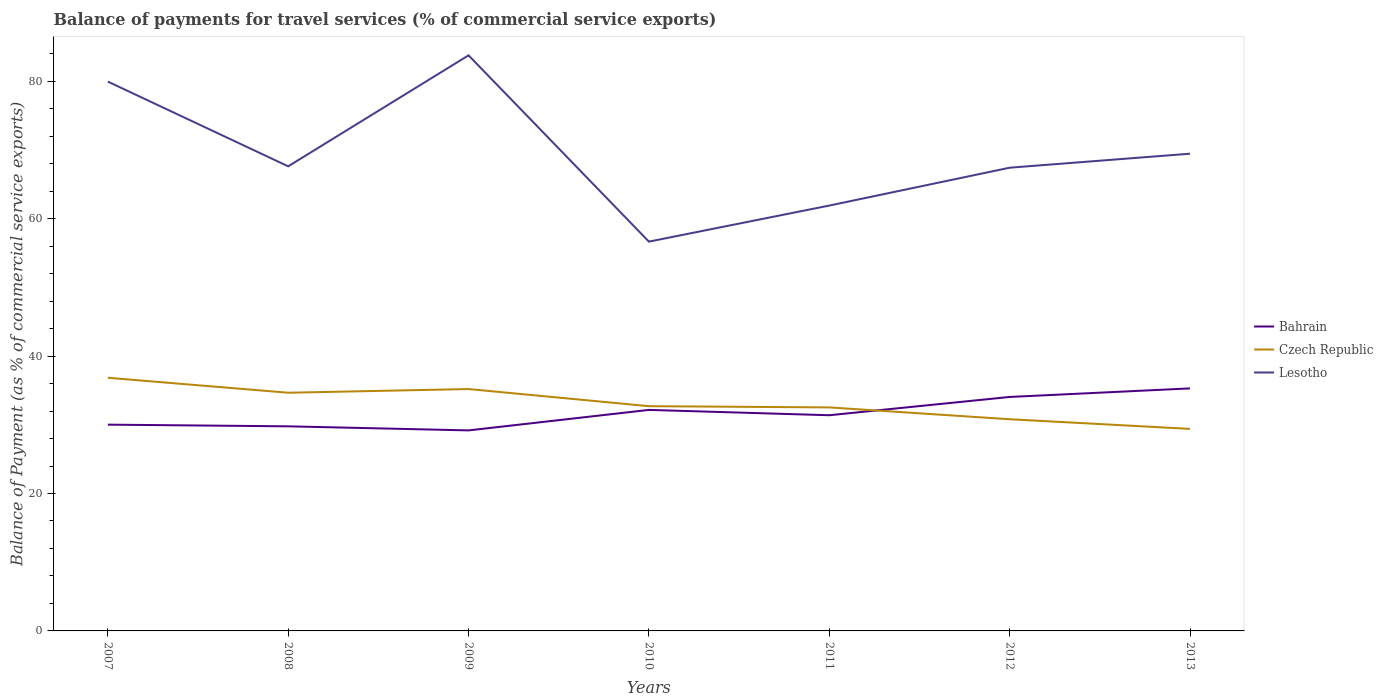Across all years, what is the maximum balance of payments for travel services in Lesotho?
Your answer should be very brief. 56.66. What is the total balance of payments for travel services in Czech Republic in the graph?
Provide a short and direct response. 6.03. What is the difference between the highest and the second highest balance of payments for travel services in Bahrain?
Ensure brevity in your answer.  6.11. How many years are there in the graph?
Keep it short and to the point. 7. Does the graph contain grids?
Your answer should be compact. No. How are the legend labels stacked?
Provide a succinct answer. Vertical. What is the title of the graph?
Your response must be concise. Balance of payments for travel services (% of commercial service exports). Does "Switzerland" appear as one of the legend labels in the graph?
Give a very brief answer. No. What is the label or title of the Y-axis?
Your response must be concise. Balance of Payment (as % of commercial service exports). What is the Balance of Payment (as % of commercial service exports) of Bahrain in 2007?
Offer a terse response. 30.02. What is the Balance of Payment (as % of commercial service exports) in Czech Republic in 2007?
Make the answer very short. 36.84. What is the Balance of Payment (as % of commercial service exports) in Lesotho in 2007?
Ensure brevity in your answer.  79.95. What is the Balance of Payment (as % of commercial service exports) of Bahrain in 2008?
Provide a succinct answer. 29.78. What is the Balance of Payment (as % of commercial service exports) in Czech Republic in 2008?
Offer a terse response. 34.67. What is the Balance of Payment (as % of commercial service exports) in Lesotho in 2008?
Give a very brief answer. 67.62. What is the Balance of Payment (as % of commercial service exports) of Bahrain in 2009?
Provide a short and direct response. 29.18. What is the Balance of Payment (as % of commercial service exports) of Czech Republic in 2009?
Your answer should be compact. 35.2. What is the Balance of Payment (as % of commercial service exports) in Lesotho in 2009?
Provide a succinct answer. 83.77. What is the Balance of Payment (as % of commercial service exports) in Bahrain in 2010?
Offer a very short reply. 32.17. What is the Balance of Payment (as % of commercial service exports) of Czech Republic in 2010?
Provide a succinct answer. 32.71. What is the Balance of Payment (as % of commercial service exports) of Lesotho in 2010?
Offer a very short reply. 56.66. What is the Balance of Payment (as % of commercial service exports) of Bahrain in 2011?
Make the answer very short. 31.39. What is the Balance of Payment (as % of commercial service exports) in Czech Republic in 2011?
Your answer should be very brief. 32.53. What is the Balance of Payment (as % of commercial service exports) in Lesotho in 2011?
Your answer should be very brief. 61.91. What is the Balance of Payment (as % of commercial service exports) of Bahrain in 2012?
Offer a terse response. 34.05. What is the Balance of Payment (as % of commercial service exports) of Czech Republic in 2012?
Offer a very short reply. 30.81. What is the Balance of Payment (as % of commercial service exports) in Lesotho in 2012?
Offer a terse response. 67.42. What is the Balance of Payment (as % of commercial service exports) of Bahrain in 2013?
Provide a succinct answer. 35.3. What is the Balance of Payment (as % of commercial service exports) in Czech Republic in 2013?
Make the answer very short. 29.4. What is the Balance of Payment (as % of commercial service exports) in Lesotho in 2013?
Keep it short and to the point. 69.46. Across all years, what is the maximum Balance of Payment (as % of commercial service exports) in Bahrain?
Your answer should be compact. 35.3. Across all years, what is the maximum Balance of Payment (as % of commercial service exports) of Czech Republic?
Give a very brief answer. 36.84. Across all years, what is the maximum Balance of Payment (as % of commercial service exports) of Lesotho?
Ensure brevity in your answer.  83.77. Across all years, what is the minimum Balance of Payment (as % of commercial service exports) of Bahrain?
Make the answer very short. 29.18. Across all years, what is the minimum Balance of Payment (as % of commercial service exports) of Czech Republic?
Your response must be concise. 29.4. Across all years, what is the minimum Balance of Payment (as % of commercial service exports) of Lesotho?
Offer a terse response. 56.66. What is the total Balance of Payment (as % of commercial service exports) of Bahrain in the graph?
Your answer should be compact. 221.89. What is the total Balance of Payment (as % of commercial service exports) in Czech Republic in the graph?
Your answer should be very brief. 232.17. What is the total Balance of Payment (as % of commercial service exports) in Lesotho in the graph?
Offer a very short reply. 486.78. What is the difference between the Balance of Payment (as % of commercial service exports) in Bahrain in 2007 and that in 2008?
Offer a very short reply. 0.25. What is the difference between the Balance of Payment (as % of commercial service exports) in Czech Republic in 2007 and that in 2008?
Provide a succinct answer. 2.18. What is the difference between the Balance of Payment (as % of commercial service exports) of Lesotho in 2007 and that in 2008?
Keep it short and to the point. 12.33. What is the difference between the Balance of Payment (as % of commercial service exports) in Bahrain in 2007 and that in 2009?
Your answer should be compact. 0.84. What is the difference between the Balance of Payment (as % of commercial service exports) in Czech Republic in 2007 and that in 2009?
Ensure brevity in your answer.  1.64. What is the difference between the Balance of Payment (as % of commercial service exports) of Lesotho in 2007 and that in 2009?
Ensure brevity in your answer.  -3.82. What is the difference between the Balance of Payment (as % of commercial service exports) in Bahrain in 2007 and that in 2010?
Give a very brief answer. -2.15. What is the difference between the Balance of Payment (as % of commercial service exports) of Czech Republic in 2007 and that in 2010?
Provide a succinct answer. 4.13. What is the difference between the Balance of Payment (as % of commercial service exports) of Lesotho in 2007 and that in 2010?
Your response must be concise. 23.29. What is the difference between the Balance of Payment (as % of commercial service exports) in Bahrain in 2007 and that in 2011?
Your response must be concise. -1.37. What is the difference between the Balance of Payment (as % of commercial service exports) in Czech Republic in 2007 and that in 2011?
Offer a very short reply. 4.31. What is the difference between the Balance of Payment (as % of commercial service exports) in Lesotho in 2007 and that in 2011?
Your response must be concise. 18.04. What is the difference between the Balance of Payment (as % of commercial service exports) of Bahrain in 2007 and that in 2012?
Ensure brevity in your answer.  -4.03. What is the difference between the Balance of Payment (as % of commercial service exports) of Czech Republic in 2007 and that in 2012?
Your answer should be compact. 6.03. What is the difference between the Balance of Payment (as % of commercial service exports) of Lesotho in 2007 and that in 2012?
Ensure brevity in your answer.  12.53. What is the difference between the Balance of Payment (as % of commercial service exports) in Bahrain in 2007 and that in 2013?
Provide a short and direct response. -5.28. What is the difference between the Balance of Payment (as % of commercial service exports) of Czech Republic in 2007 and that in 2013?
Your answer should be compact. 7.44. What is the difference between the Balance of Payment (as % of commercial service exports) of Lesotho in 2007 and that in 2013?
Your answer should be very brief. 10.5. What is the difference between the Balance of Payment (as % of commercial service exports) of Bahrain in 2008 and that in 2009?
Your response must be concise. 0.59. What is the difference between the Balance of Payment (as % of commercial service exports) of Czech Republic in 2008 and that in 2009?
Offer a very short reply. -0.54. What is the difference between the Balance of Payment (as % of commercial service exports) in Lesotho in 2008 and that in 2009?
Offer a very short reply. -16.15. What is the difference between the Balance of Payment (as % of commercial service exports) in Bahrain in 2008 and that in 2010?
Your answer should be very brief. -2.39. What is the difference between the Balance of Payment (as % of commercial service exports) in Czech Republic in 2008 and that in 2010?
Provide a short and direct response. 1.96. What is the difference between the Balance of Payment (as % of commercial service exports) of Lesotho in 2008 and that in 2010?
Give a very brief answer. 10.96. What is the difference between the Balance of Payment (as % of commercial service exports) of Bahrain in 2008 and that in 2011?
Keep it short and to the point. -1.61. What is the difference between the Balance of Payment (as % of commercial service exports) of Czech Republic in 2008 and that in 2011?
Your answer should be compact. 2.14. What is the difference between the Balance of Payment (as % of commercial service exports) in Lesotho in 2008 and that in 2011?
Make the answer very short. 5.71. What is the difference between the Balance of Payment (as % of commercial service exports) in Bahrain in 2008 and that in 2012?
Keep it short and to the point. -4.28. What is the difference between the Balance of Payment (as % of commercial service exports) in Czech Republic in 2008 and that in 2012?
Give a very brief answer. 3.86. What is the difference between the Balance of Payment (as % of commercial service exports) of Lesotho in 2008 and that in 2012?
Keep it short and to the point. 0.2. What is the difference between the Balance of Payment (as % of commercial service exports) in Bahrain in 2008 and that in 2013?
Make the answer very short. -5.52. What is the difference between the Balance of Payment (as % of commercial service exports) in Czech Republic in 2008 and that in 2013?
Provide a succinct answer. 5.26. What is the difference between the Balance of Payment (as % of commercial service exports) in Lesotho in 2008 and that in 2013?
Provide a succinct answer. -1.84. What is the difference between the Balance of Payment (as % of commercial service exports) in Bahrain in 2009 and that in 2010?
Your answer should be compact. -2.98. What is the difference between the Balance of Payment (as % of commercial service exports) in Czech Republic in 2009 and that in 2010?
Your answer should be very brief. 2.49. What is the difference between the Balance of Payment (as % of commercial service exports) in Lesotho in 2009 and that in 2010?
Your response must be concise. 27.11. What is the difference between the Balance of Payment (as % of commercial service exports) in Bahrain in 2009 and that in 2011?
Offer a terse response. -2.21. What is the difference between the Balance of Payment (as % of commercial service exports) in Czech Republic in 2009 and that in 2011?
Offer a very short reply. 2.67. What is the difference between the Balance of Payment (as % of commercial service exports) in Lesotho in 2009 and that in 2011?
Offer a terse response. 21.87. What is the difference between the Balance of Payment (as % of commercial service exports) in Bahrain in 2009 and that in 2012?
Provide a succinct answer. -4.87. What is the difference between the Balance of Payment (as % of commercial service exports) in Czech Republic in 2009 and that in 2012?
Keep it short and to the point. 4.39. What is the difference between the Balance of Payment (as % of commercial service exports) of Lesotho in 2009 and that in 2012?
Ensure brevity in your answer.  16.36. What is the difference between the Balance of Payment (as % of commercial service exports) of Bahrain in 2009 and that in 2013?
Your answer should be very brief. -6.11. What is the difference between the Balance of Payment (as % of commercial service exports) in Czech Republic in 2009 and that in 2013?
Provide a succinct answer. 5.8. What is the difference between the Balance of Payment (as % of commercial service exports) in Lesotho in 2009 and that in 2013?
Your answer should be very brief. 14.32. What is the difference between the Balance of Payment (as % of commercial service exports) in Bahrain in 2010 and that in 2011?
Your answer should be very brief. 0.78. What is the difference between the Balance of Payment (as % of commercial service exports) in Czech Republic in 2010 and that in 2011?
Make the answer very short. 0.18. What is the difference between the Balance of Payment (as % of commercial service exports) of Lesotho in 2010 and that in 2011?
Offer a terse response. -5.25. What is the difference between the Balance of Payment (as % of commercial service exports) of Bahrain in 2010 and that in 2012?
Offer a very short reply. -1.88. What is the difference between the Balance of Payment (as % of commercial service exports) in Czech Republic in 2010 and that in 2012?
Ensure brevity in your answer.  1.9. What is the difference between the Balance of Payment (as % of commercial service exports) of Lesotho in 2010 and that in 2012?
Provide a succinct answer. -10.76. What is the difference between the Balance of Payment (as % of commercial service exports) in Bahrain in 2010 and that in 2013?
Offer a terse response. -3.13. What is the difference between the Balance of Payment (as % of commercial service exports) of Czech Republic in 2010 and that in 2013?
Ensure brevity in your answer.  3.31. What is the difference between the Balance of Payment (as % of commercial service exports) in Lesotho in 2010 and that in 2013?
Make the answer very short. -12.8. What is the difference between the Balance of Payment (as % of commercial service exports) of Bahrain in 2011 and that in 2012?
Your answer should be very brief. -2.66. What is the difference between the Balance of Payment (as % of commercial service exports) in Czech Republic in 2011 and that in 2012?
Offer a terse response. 1.72. What is the difference between the Balance of Payment (as % of commercial service exports) of Lesotho in 2011 and that in 2012?
Provide a succinct answer. -5.51. What is the difference between the Balance of Payment (as % of commercial service exports) in Bahrain in 2011 and that in 2013?
Offer a very short reply. -3.91. What is the difference between the Balance of Payment (as % of commercial service exports) of Czech Republic in 2011 and that in 2013?
Give a very brief answer. 3.13. What is the difference between the Balance of Payment (as % of commercial service exports) of Lesotho in 2011 and that in 2013?
Offer a terse response. -7.55. What is the difference between the Balance of Payment (as % of commercial service exports) in Bahrain in 2012 and that in 2013?
Your response must be concise. -1.25. What is the difference between the Balance of Payment (as % of commercial service exports) in Czech Republic in 2012 and that in 2013?
Provide a short and direct response. 1.4. What is the difference between the Balance of Payment (as % of commercial service exports) in Lesotho in 2012 and that in 2013?
Your answer should be compact. -2.04. What is the difference between the Balance of Payment (as % of commercial service exports) of Bahrain in 2007 and the Balance of Payment (as % of commercial service exports) of Czech Republic in 2008?
Provide a succinct answer. -4.64. What is the difference between the Balance of Payment (as % of commercial service exports) of Bahrain in 2007 and the Balance of Payment (as % of commercial service exports) of Lesotho in 2008?
Ensure brevity in your answer.  -37.6. What is the difference between the Balance of Payment (as % of commercial service exports) of Czech Republic in 2007 and the Balance of Payment (as % of commercial service exports) of Lesotho in 2008?
Offer a terse response. -30.77. What is the difference between the Balance of Payment (as % of commercial service exports) of Bahrain in 2007 and the Balance of Payment (as % of commercial service exports) of Czech Republic in 2009?
Your answer should be very brief. -5.18. What is the difference between the Balance of Payment (as % of commercial service exports) of Bahrain in 2007 and the Balance of Payment (as % of commercial service exports) of Lesotho in 2009?
Give a very brief answer. -53.75. What is the difference between the Balance of Payment (as % of commercial service exports) of Czech Republic in 2007 and the Balance of Payment (as % of commercial service exports) of Lesotho in 2009?
Make the answer very short. -46.93. What is the difference between the Balance of Payment (as % of commercial service exports) in Bahrain in 2007 and the Balance of Payment (as % of commercial service exports) in Czech Republic in 2010?
Your answer should be very brief. -2.69. What is the difference between the Balance of Payment (as % of commercial service exports) of Bahrain in 2007 and the Balance of Payment (as % of commercial service exports) of Lesotho in 2010?
Keep it short and to the point. -26.64. What is the difference between the Balance of Payment (as % of commercial service exports) in Czech Republic in 2007 and the Balance of Payment (as % of commercial service exports) in Lesotho in 2010?
Your response must be concise. -19.81. What is the difference between the Balance of Payment (as % of commercial service exports) of Bahrain in 2007 and the Balance of Payment (as % of commercial service exports) of Czech Republic in 2011?
Your answer should be compact. -2.51. What is the difference between the Balance of Payment (as % of commercial service exports) in Bahrain in 2007 and the Balance of Payment (as % of commercial service exports) in Lesotho in 2011?
Make the answer very short. -31.88. What is the difference between the Balance of Payment (as % of commercial service exports) of Czech Republic in 2007 and the Balance of Payment (as % of commercial service exports) of Lesotho in 2011?
Your answer should be very brief. -25.06. What is the difference between the Balance of Payment (as % of commercial service exports) of Bahrain in 2007 and the Balance of Payment (as % of commercial service exports) of Czech Republic in 2012?
Your answer should be compact. -0.79. What is the difference between the Balance of Payment (as % of commercial service exports) in Bahrain in 2007 and the Balance of Payment (as % of commercial service exports) in Lesotho in 2012?
Provide a short and direct response. -37.4. What is the difference between the Balance of Payment (as % of commercial service exports) in Czech Republic in 2007 and the Balance of Payment (as % of commercial service exports) in Lesotho in 2012?
Your answer should be very brief. -30.57. What is the difference between the Balance of Payment (as % of commercial service exports) in Bahrain in 2007 and the Balance of Payment (as % of commercial service exports) in Czech Republic in 2013?
Your answer should be compact. 0.62. What is the difference between the Balance of Payment (as % of commercial service exports) in Bahrain in 2007 and the Balance of Payment (as % of commercial service exports) in Lesotho in 2013?
Your answer should be compact. -39.43. What is the difference between the Balance of Payment (as % of commercial service exports) of Czech Republic in 2007 and the Balance of Payment (as % of commercial service exports) of Lesotho in 2013?
Your answer should be very brief. -32.61. What is the difference between the Balance of Payment (as % of commercial service exports) of Bahrain in 2008 and the Balance of Payment (as % of commercial service exports) of Czech Republic in 2009?
Your response must be concise. -5.43. What is the difference between the Balance of Payment (as % of commercial service exports) of Bahrain in 2008 and the Balance of Payment (as % of commercial service exports) of Lesotho in 2009?
Provide a succinct answer. -54. What is the difference between the Balance of Payment (as % of commercial service exports) in Czech Republic in 2008 and the Balance of Payment (as % of commercial service exports) in Lesotho in 2009?
Offer a very short reply. -49.11. What is the difference between the Balance of Payment (as % of commercial service exports) in Bahrain in 2008 and the Balance of Payment (as % of commercial service exports) in Czech Republic in 2010?
Offer a terse response. -2.93. What is the difference between the Balance of Payment (as % of commercial service exports) of Bahrain in 2008 and the Balance of Payment (as % of commercial service exports) of Lesotho in 2010?
Keep it short and to the point. -26.88. What is the difference between the Balance of Payment (as % of commercial service exports) of Czech Republic in 2008 and the Balance of Payment (as % of commercial service exports) of Lesotho in 2010?
Offer a very short reply. -21.99. What is the difference between the Balance of Payment (as % of commercial service exports) of Bahrain in 2008 and the Balance of Payment (as % of commercial service exports) of Czech Republic in 2011?
Provide a short and direct response. -2.75. What is the difference between the Balance of Payment (as % of commercial service exports) of Bahrain in 2008 and the Balance of Payment (as % of commercial service exports) of Lesotho in 2011?
Offer a very short reply. -32.13. What is the difference between the Balance of Payment (as % of commercial service exports) of Czech Republic in 2008 and the Balance of Payment (as % of commercial service exports) of Lesotho in 2011?
Keep it short and to the point. -27.24. What is the difference between the Balance of Payment (as % of commercial service exports) in Bahrain in 2008 and the Balance of Payment (as % of commercial service exports) in Czech Republic in 2012?
Provide a succinct answer. -1.03. What is the difference between the Balance of Payment (as % of commercial service exports) of Bahrain in 2008 and the Balance of Payment (as % of commercial service exports) of Lesotho in 2012?
Provide a succinct answer. -37.64. What is the difference between the Balance of Payment (as % of commercial service exports) of Czech Republic in 2008 and the Balance of Payment (as % of commercial service exports) of Lesotho in 2012?
Provide a short and direct response. -32.75. What is the difference between the Balance of Payment (as % of commercial service exports) in Bahrain in 2008 and the Balance of Payment (as % of commercial service exports) in Czech Republic in 2013?
Ensure brevity in your answer.  0.37. What is the difference between the Balance of Payment (as % of commercial service exports) in Bahrain in 2008 and the Balance of Payment (as % of commercial service exports) in Lesotho in 2013?
Your response must be concise. -39.68. What is the difference between the Balance of Payment (as % of commercial service exports) in Czech Republic in 2008 and the Balance of Payment (as % of commercial service exports) in Lesotho in 2013?
Provide a short and direct response. -34.79. What is the difference between the Balance of Payment (as % of commercial service exports) in Bahrain in 2009 and the Balance of Payment (as % of commercial service exports) in Czech Republic in 2010?
Provide a short and direct response. -3.53. What is the difference between the Balance of Payment (as % of commercial service exports) of Bahrain in 2009 and the Balance of Payment (as % of commercial service exports) of Lesotho in 2010?
Ensure brevity in your answer.  -27.47. What is the difference between the Balance of Payment (as % of commercial service exports) of Czech Republic in 2009 and the Balance of Payment (as % of commercial service exports) of Lesotho in 2010?
Keep it short and to the point. -21.46. What is the difference between the Balance of Payment (as % of commercial service exports) in Bahrain in 2009 and the Balance of Payment (as % of commercial service exports) in Czech Republic in 2011?
Keep it short and to the point. -3.35. What is the difference between the Balance of Payment (as % of commercial service exports) in Bahrain in 2009 and the Balance of Payment (as % of commercial service exports) in Lesotho in 2011?
Make the answer very short. -32.72. What is the difference between the Balance of Payment (as % of commercial service exports) in Czech Republic in 2009 and the Balance of Payment (as % of commercial service exports) in Lesotho in 2011?
Your answer should be compact. -26.7. What is the difference between the Balance of Payment (as % of commercial service exports) of Bahrain in 2009 and the Balance of Payment (as % of commercial service exports) of Czech Republic in 2012?
Your answer should be compact. -1.62. What is the difference between the Balance of Payment (as % of commercial service exports) in Bahrain in 2009 and the Balance of Payment (as % of commercial service exports) in Lesotho in 2012?
Offer a terse response. -38.23. What is the difference between the Balance of Payment (as % of commercial service exports) of Czech Republic in 2009 and the Balance of Payment (as % of commercial service exports) of Lesotho in 2012?
Your answer should be compact. -32.21. What is the difference between the Balance of Payment (as % of commercial service exports) of Bahrain in 2009 and the Balance of Payment (as % of commercial service exports) of Czech Republic in 2013?
Your response must be concise. -0.22. What is the difference between the Balance of Payment (as % of commercial service exports) in Bahrain in 2009 and the Balance of Payment (as % of commercial service exports) in Lesotho in 2013?
Offer a very short reply. -40.27. What is the difference between the Balance of Payment (as % of commercial service exports) in Czech Republic in 2009 and the Balance of Payment (as % of commercial service exports) in Lesotho in 2013?
Your answer should be compact. -34.25. What is the difference between the Balance of Payment (as % of commercial service exports) in Bahrain in 2010 and the Balance of Payment (as % of commercial service exports) in Czech Republic in 2011?
Keep it short and to the point. -0.36. What is the difference between the Balance of Payment (as % of commercial service exports) of Bahrain in 2010 and the Balance of Payment (as % of commercial service exports) of Lesotho in 2011?
Make the answer very short. -29.74. What is the difference between the Balance of Payment (as % of commercial service exports) in Czech Republic in 2010 and the Balance of Payment (as % of commercial service exports) in Lesotho in 2011?
Your answer should be very brief. -29.2. What is the difference between the Balance of Payment (as % of commercial service exports) of Bahrain in 2010 and the Balance of Payment (as % of commercial service exports) of Czech Republic in 2012?
Your response must be concise. 1.36. What is the difference between the Balance of Payment (as % of commercial service exports) of Bahrain in 2010 and the Balance of Payment (as % of commercial service exports) of Lesotho in 2012?
Offer a terse response. -35.25. What is the difference between the Balance of Payment (as % of commercial service exports) in Czech Republic in 2010 and the Balance of Payment (as % of commercial service exports) in Lesotho in 2012?
Your answer should be very brief. -34.71. What is the difference between the Balance of Payment (as % of commercial service exports) in Bahrain in 2010 and the Balance of Payment (as % of commercial service exports) in Czech Republic in 2013?
Provide a short and direct response. 2.76. What is the difference between the Balance of Payment (as % of commercial service exports) in Bahrain in 2010 and the Balance of Payment (as % of commercial service exports) in Lesotho in 2013?
Your answer should be very brief. -37.29. What is the difference between the Balance of Payment (as % of commercial service exports) in Czech Republic in 2010 and the Balance of Payment (as % of commercial service exports) in Lesotho in 2013?
Provide a short and direct response. -36.74. What is the difference between the Balance of Payment (as % of commercial service exports) in Bahrain in 2011 and the Balance of Payment (as % of commercial service exports) in Czech Republic in 2012?
Make the answer very short. 0.58. What is the difference between the Balance of Payment (as % of commercial service exports) of Bahrain in 2011 and the Balance of Payment (as % of commercial service exports) of Lesotho in 2012?
Offer a very short reply. -36.03. What is the difference between the Balance of Payment (as % of commercial service exports) of Czech Republic in 2011 and the Balance of Payment (as % of commercial service exports) of Lesotho in 2012?
Provide a short and direct response. -34.89. What is the difference between the Balance of Payment (as % of commercial service exports) of Bahrain in 2011 and the Balance of Payment (as % of commercial service exports) of Czech Republic in 2013?
Your answer should be very brief. 1.99. What is the difference between the Balance of Payment (as % of commercial service exports) of Bahrain in 2011 and the Balance of Payment (as % of commercial service exports) of Lesotho in 2013?
Make the answer very short. -38.06. What is the difference between the Balance of Payment (as % of commercial service exports) of Czech Republic in 2011 and the Balance of Payment (as % of commercial service exports) of Lesotho in 2013?
Your answer should be compact. -36.92. What is the difference between the Balance of Payment (as % of commercial service exports) in Bahrain in 2012 and the Balance of Payment (as % of commercial service exports) in Czech Republic in 2013?
Ensure brevity in your answer.  4.65. What is the difference between the Balance of Payment (as % of commercial service exports) in Bahrain in 2012 and the Balance of Payment (as % of commercial service exports) in Lesotho in 2013?
Provide a short and direct response. -35.4. What is the difference between the Balance of Payment (as % of commercial service exports) of Czech Republic in 2012 and the Balance of Payment (as % of commercial service exports) of Lesotho in 2013?
Your answer should be compact. -38.65. What is the average Balance of Payment (as % of commercial service exports) in Bahrain per year?
Your answer should be very brief. 31.7. What is the average Balance of Payment (as % of commercial service exports) in Czech Republic per year?
Keep it short and to the point. 33.17. What is the average Balance of Payment (as % of commercial service exports) in Lesotho per year?
Your response must be concise. 69.54. In the year 2007, what is the difference between the Balance of Payment (as % of commercial service exports) of Bahrain and Balance of Payment (as % of commercial service exports) of Czech Republic?
Your response must be concise. -6.82. In the year 2007, what is the difference between the Balance of Payment (as % of commercial service exports) of Bahrain and Balance of Payment (as % of commercial service exports) of Lesotho?
Your answer should be very brief. -49.93. In the year 2007, what is the difference between the Balance of Payment (as % of commercial service exports) in Czech Republic and Balance of Payment (as % of commercial service exports) in Lesotho?
Provide a short and direct response. -43.11. In the year 2008, what is the difference between the Balance of Payment (as % of commercial service exports) of Bahrain and Balance of Payment (as % of commercial service exports) of Czech Republic?
Keep it short and to the point. -4.89. In the year 2008, what is the difference between the Balance of Payment (as % of commercial service exports) of Bahrain and Balance of Payment (as % of commercial service exports) of Lesotho?
Offer a very short reply. -37.84. In the year 2008, what is the difference between the Balance of Payment (as % of commercial service exports) in Czech Republic and Balance of Payment (as % of commercial service exports) in Lesotho?
Ensure brevity in your answer.  -32.95. In the year 2009, what is the difference between the Balance of Payment (as % of commercial service exports) in Bahrain and Balance of Payment (as % of commercial service exports) in Czech Republic?
Your answer should be very brief. -6.02. In the year 2009, what is the difference between the Balance of Payment (as % of commercial service exports) in Bahrain and Balance of Payment (as % of commercial service exports) in Lesotho?
Ensure brevity in your answer.  -54.59. In the year 2009, what is the difference between the Balance of Payment (as % of commercial service exports) of Czech Republic and Balance of Payment (as % of commercial service exports) of Lesotho?
Your answer should be very brief. -48.57. In the year 2010, what is the difference between the Balance of Payment (as % of commercial service exports) in Bahrain and Balance of Payment (as % of commercial service exports) in Czech Republic?
Give a very brief answer. -0.54. In the year 2010, what is the difference between the Balance of Payment (as % of commercial service exports) in Bahrain and Balance of Payment (as % of commercial service exports) in Lesotho?
Offer a terse response. -24.49. In the year 2010, what is the difference between the Balance of Payment (as % of commercial service exports) in Czech Republic and Balance of Payment (as % of commercial service exports) in Lesotho?
Provide a succinct answer. -23.95. In the year 2011, what is the difference between the Balance of Payment (as % of commercial service exports) in Bahrain and Balance of Payment (as % of commercial service exports) in Czech Republic?
Keep it short and to the point. -1.14. In the year 2011, what is the difference between the Balance of Payment (as % of commercial service exports) in Bahrain and Balance of Payment (as % of commercial service exports) in Lesotho?
Offer a terse response. -30.52. In the year 2011, what is the difference between the Balance of Payment (as % of commercial service exports) in Czech Republic and Balance of Payment (as % of commercial service exports) in Lesotho?
Provide a short and direct response. -29.38. In the year 2012, what is the difference between the Balance of Payment (as % of commercial service exports) in Bahrain and Balance of Payment (as % of commercial service exports) in Czech Republic?
Your response must be concise. 3.24. In the year 2012, what is the difference between the Balance of Payment (as % of commercial service exports) of Bahrain and Balance of Payment (as % of commercial service exports) of Lesotho?
Provide a short and direct response. -33.37. In the year 2012, what is the difference between the Balance of Payment (as % of commercial service exports) in Czech Republic and Balance of Payment (as % of commercial service exports) in Lesotho?
Offer a very short reply. -36.61. In the year 2013, what is the difference between the Balance of Payment (as % of commercial service exports) in Bahrain and Balance of Payment (as % of commercial service exports) in Czech Republic?
Provide a succinct answer. 5.89. In the year 2013, what is the difference between the Balance of Payment (as % of commercial service exports) in Bahrain and Balance of Payment (as % of commercial service exports) in Lesotho?
Provide a succinct answer. -34.16. In the year 2013, what is the difference between the Balance of Payment (as % of commercial service exports) in Czech Republic and Balance of Payment (as % of commercial service exports) in Lesotho?
Make the answer very short. -40.05. What is the ratio of the Balance of Payment (as % of commercial service exports) in Bahrain in 2007 to that in 2008?
Your answer should be very brief. 1.01. What is the ratio of the Balance of Payment (as % of commercial service exports) in Czech Republic in 2007 to that in 2008?
Make the answer very short. 1.06. What is the ratio of the Balance of Payment (as % of commercial service exports) in Lesotho in 2007 to that in 2008?
Make the answer very short. 1.18. What is the ratio of the Balance of Payment (as % of commercial service exports) of Bahrain in 2007 to that in 2009?
Give a very brief answer. 1.03. What is the ratio of the Balance of Payment (as % of commercial service exports) in Czech Republic in 2007 to that in 2009?
Your answer should be compact. 1.05. What is the ratio of the Balance of Payment (as % of commercial service exports) in Lesotho in 2007 to that in 2009?
Your answer should be compact. 0.95. What is the ratio of the Balance of Payment (as % of commercial service exports) in Czech Republic in 2007 to that in 2010?
Keep it short and to the point. 1.13. What is the ratio of the Balance of Payment (as % of commercial service exports) of Lesotho in 2007 to that in 2010?
Your answer should be very brief. 1.41. What is the ratio of the Balance of Payment (as % of commercial service exports) of Bahrain in 2007 to that in 2011?
Your answer should be very brief. 0.96. What is the ratio of the Balance of Payment (as % of commercial service exports) of Czech Republic in 2007 to that in 2011?
Your answer should be compact. 1.13. What is the ratio of the Balance of Payment (as % of commercial service exports) in Lesotho in 2007 to that in 2011?
Provide a succinct answer. 1.29. What is the ratio of the Balance of Payment (as % of commercial service exports) of Bahrain in 2007 to that in 2012?
Provide a succinct answer. 0.88. What is the ratio of the Balance of Payment (as % of commercial service exports) of Czech Republic in 2007 to that in 2012?
Provide a succinct answer. 1.2. What is the ratio of the Balance of Payment (as % of commercial service exports) in Lesotho in 2007 to that in 2012?
Your answer should be very brief. 1.19. What is the ratio of the Balance of Payment (as % of commercial service exports) of Bahrain in 2007 to that in 2013?
Make the answer very short. 0.85. What is the ratio of the Balance of Payment (as % of commercial service exports) in Czech Republic in 2007 to that in 2013?
Make the answer very short. 1.25. What is the ratio of the Balance of Payment (as % of commercial service exports) in Lesotho in 2007 to that in 2013?
Offer a very short reply. 1.15. What is the ratio of the Balance of Payment (as % of commercial service exports) in Bahrain in 2008 to that in 2009?
Offer a very short reply. 1.02. What is the ratio of the Balance of Payment (as % of commercial service exports) in Lesotho in 2008 to that in 2009?
Provide a short and direct response. 0.81. What is the ratio of the Balance of Payment (as % of commercial service exports) in Bahrain in 2008 to that in 2010?
Your response must be concise. 0.93. What is the ratio of the Balance of Payment (as % of commercial service exports) of Czech Republic in 2008 to that in 2010?
Ensure brevity in your answer.  1.06. What is the ratio of the Balance of Payment (as % of commercial service exports) in Lesotho in 2008 to that in 2010?
Ensure brevity in your answer.  1.19. What is the ratio of the Balance of Payment (as % of commercial service exports) in Bahrain in 2008 to that in 2011?
Provide a succinct answer. 0.95. What is the ratio of the Balance of Payment (as % of commercial service exports) in Czech Republic in 2008 to that in 2011?
Make the answer very short. 1.07. What is the ratio of the Balance of Payment (as % of commercial service exports) in Lesotho in 2008 to that in 2011?
Your answer should be compact. 1.09. What is the ratio of the Balance of Payment (as % of commercial service exports) of Bahrain in 2008 to that in 2012?
Provide a succinct answer. 0.87. What is the ratio of the Balance of Payment (as % of commercial service exports) of Czech Republic in 2008 to that in 2012?
Give a very brief answer. 1.13. What is the ratio of the Balance of Payment (as % of commercial service exports) in Bahrain in 2008 to that in 2013?
Ensure brevity in your answer.  0.84. What is the ratio of the Balance of Payment (as % of commercial service exports) in Czech Republic in 2008 to that in 2013?
Ensure brevity in your answer.  1.18. What is the ratio of the Balance of Payment (as % of commercial service exports) in Lesotho in 2008 to that in 2013?
Make the answer very short. 0.97. What is the ratio of the Balance of Payment (as % of commercial service exports) in Bahrain in 2009 to that in 2010?
Your answer should be compact. 0.91. What is the ratio of the Balance of Payment (as % of commercial service exports) of Czech Republic in 2009 to that in 2010?
Give a very brief answer. 1.08. What is the ratio of the Balance of Payment (as % of commercial service exports) in Lesotho in 2009 to that in 2010?
Provide a succinct answer. 1.48. What is the ratio of the Balance of Payment (as % of commercial service exports) of Bahrain in 2009 to that in 2011?
Provide a short and direct response. 0.93. What is the ratio of the Balance of Payment (as % of commercial service exports) of Czech Republic in 2009 to that in 2011?
Give a very brief answer. 1.08. What is the ratio of the Balance of Payment (as % of commercial service exports) of Lesotho in 2009 to that in 2011?
Your answer should be compact. 1.35. What is the ratio of the Balance of Payment (as % of commercial service exports) of Bahrain in 2009 to that in 2012?
Make the answer very short. 0.86. What is the ratio of the Balance of Payment (as % of commercial service exports) of Czech Republic in 2009 to that in 2012?
Give a very brief answer. 1.14. What is the ratio of the Balance of Payment (as % of commercial service exports) of Lesotho in 2009 to that in 2012?
Offer a very short reply. 1.24. What is the ratio of the Balance of Payment (as % of commercial service exports) in Bahrain in 2009 to that in 2013?
Make the answer very short. 0.83. What is the ratio of the Balance of Payment (as % of commercial service exports) in Czech Republic in 2009 to that in 2013?
Your answer should be compact. 1.2. What is the ratio of the Balance of Payment (as % of commercial service exports) of Lesotho in 2009 to that in 2013?
Your response must be concise. 1.21. What is the ratio of the Balance of Payment (as % of commercial service exports) in Bahrain in 2010 to that in 2011?
Provide a short and direct response. 1.02. What is the ratio of the Balance of Payment (as % of commercial service exports) of Czech Republic in 2010 to that in 2011?
Offer a very short reply. 1.01. What is the ratio of the Balance of Payment (as % of commercial service exports) of Lesotho in 2010 to that in 2011?
Offer a very short reply. 0.92. What is the ratio of the Balance of Payment (as % of commercial service exports) of Bahrain in 2010 to that in 2012?
Give a very brief answer. 0.94. What is the ratio of the Balance of Payment (as % of commercial service exports) in Czech Republic in 2010 to that in 2012?
Keep it short and to the point. 1.06. What is the ratio of the Balance of Payment (as % of commercial service exports) in Lesotho in 2010 to that in 2012?
Your response must be concise. 0.84. What is the ratio of the Balance of Payment (as % of commercial service exports) in Bahrain in 2010 to that in 2013?
Offer a terse response. 0.91. What is the ratio of the Balance of Payment (as % of commercial service exports) in Czech Republic in 2010 to that in 2013?
Make the answer very short. 1.11. What is the ratio of the Balance of Payment (as % of commercial service exports) in Lesotho in 2010 to that in 2013?
Provide a short and direct response. 0.82. What is the ratio of the Balance of Payment (as % of commercial service exports) in Bahrain in 2011 to that in 2012?
Give a very brief answer. 0.92. What is the ratio of the Balance of Payment (as % of commercial service exports) in Czech Republic in 2011 to that in 2012?
Keep it short and to the point. 1.06. What is the ratio of the Balance of Payment (as % of commercial service exports) in Lesotho in 2011 to that in 2012?
Provide a short and direct response. 0.92. What is the ratio of the Balance of Payment (as % of commercial service exports) of Bahrain in 2011 to that in 2013?
Your answer should be very brief. 0.89. What is the ratio of the Balance of Payment (as % of commercial service exports) in Czech Republic in 2011 to that in 2013?
Your answer should be very brief. 1.11. What is the ratio of the Balance of Payment (as % of commercial service exports) in Lesotho in 2011 to that in 2013?
Give a very brief answer. 0.89. What is the ratio of the Balance of Payment (as % of commercial service exports) in Bahrain in 2012 to that in 2013?
Your answer should be compact. 0.96. What is the ratio of the Balance of Payment (as % of commercial service exports) of Czech Republic in 2012 to that in 2013?
Your answer should be very brief. 1.05. What is the ratio of the Balance of Payment (as % of commercial service exports) of Lesotho in 2012 to that in 2013?
Provide a short and direct response. 0.97. What is the difference between the highest and the second highest Balance of Payment (as % of commercial service exports) in Bahrain?
Make the answer very short. 1.25. What is the difference between the highest and the second highest Balance of Payment (as % of commercial service exports) of Czech Republic?
Your response must be concise. 1.64. What is the difference between the highest and the second highest Balance of Payment (as % of commercial service exports) in Lesotho?
Your response must be concise. 3.82. What is the difference between the highest and the lowest Balance of Payment (as % of commercial service exports) of Bahrain?
Ensure brevity in your answer.  6.11. What is the difference between the highest and the lowest Balance of Payment (as % of commercial service exports) of Czech Republic?
Offer a terse response. 7.44. What is the difference between the highest and the lowest Balance of Payment (as % of commercial service exports) in Lesotho?
Your response must be concise. 27.11. 